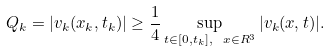<formula> <loc_0><loc_0><loc_500><loc_500>Q _ { k } = | v _ { k } ( x _ { k } , t _ { k } ) | \geq \frac { 1 } { 4 } \sup _ { t \in [ 0 , t _ { k } ] , \ x \in R ^ { 3 } } | v _ { k } ( x , t ) | .</formula> 